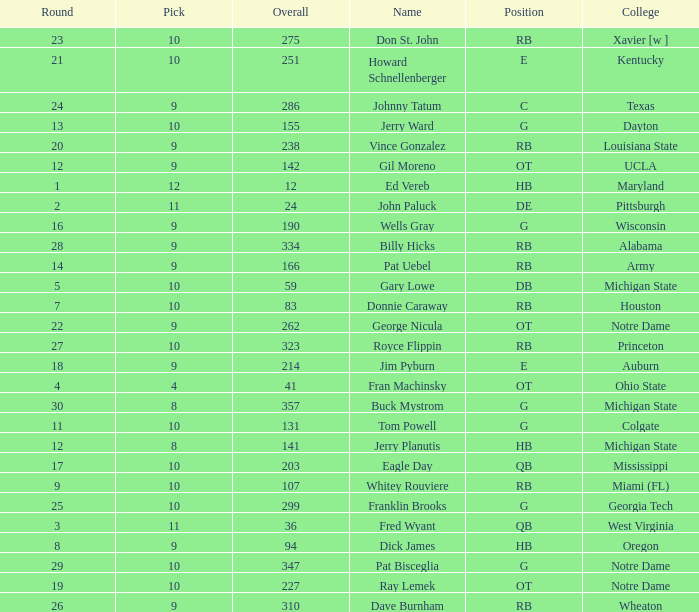What is the highest overall pick number for george nicula who had a pick smaller than 9? None. 